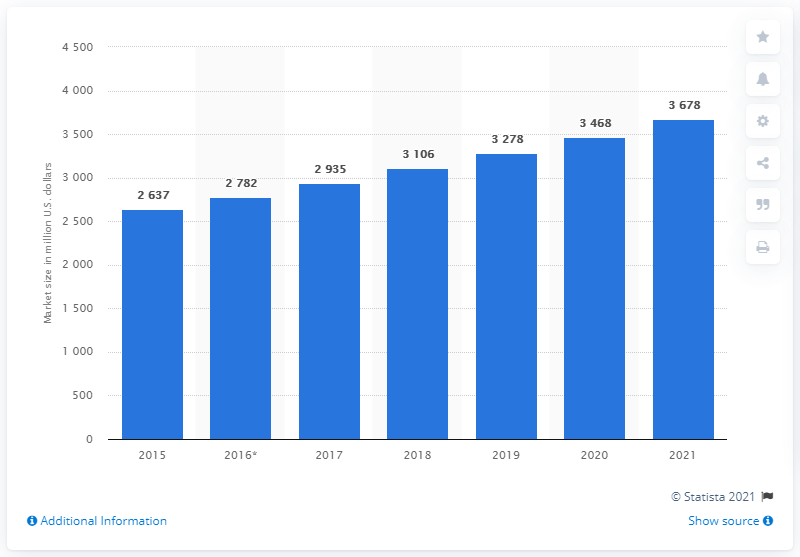Give some essential details in this illustration. In 2016, the market value of foot orthotic insoles was estimated to be approximately 2,782. The forecast value of the foot orthotic insole market is expected to reach [3678] by 2021. 